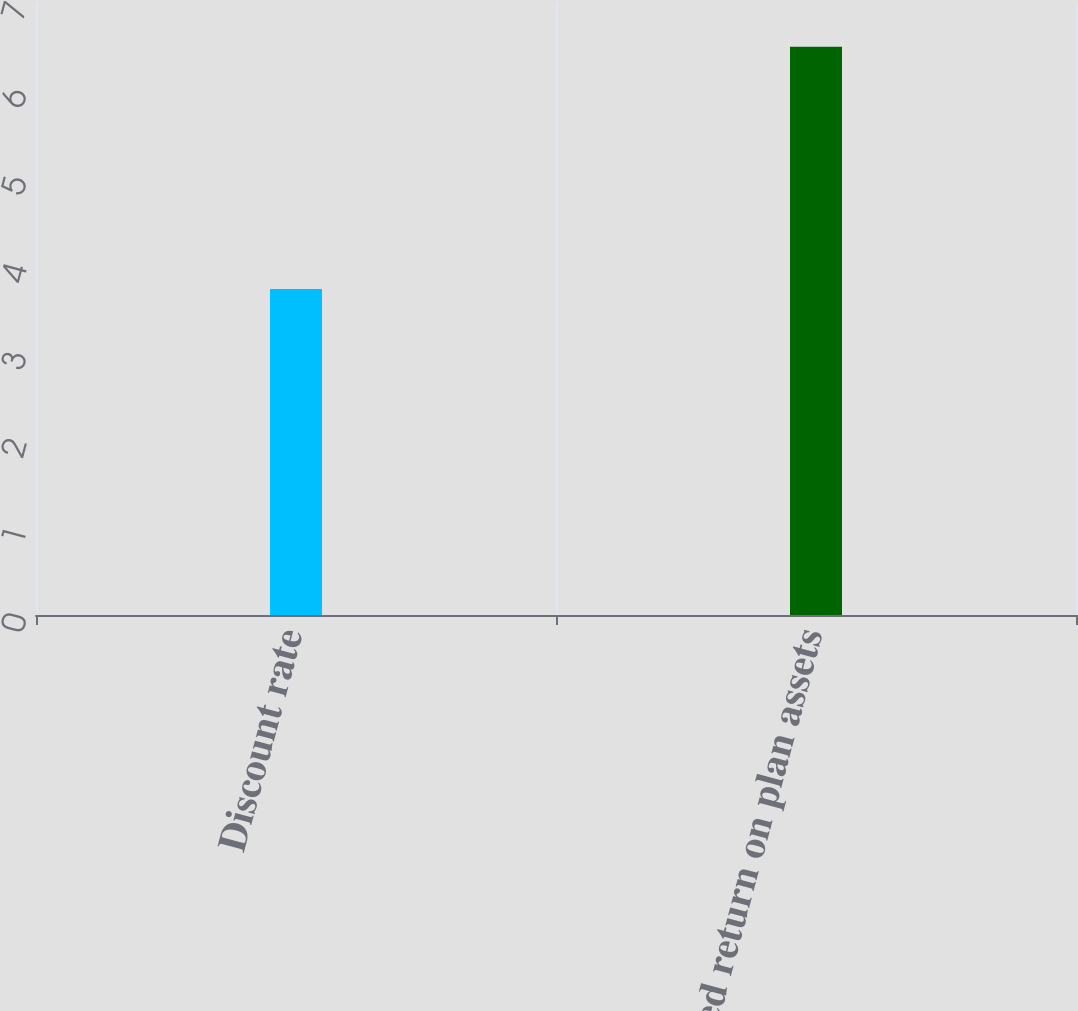<chart> <loc_0><loc_0><loc_500><loc_500><bar_chart><fcel>Discount rate<fcel>Expected return on plan assets<nl><fcel>3.73<fcel>6.5<nl></chart> 